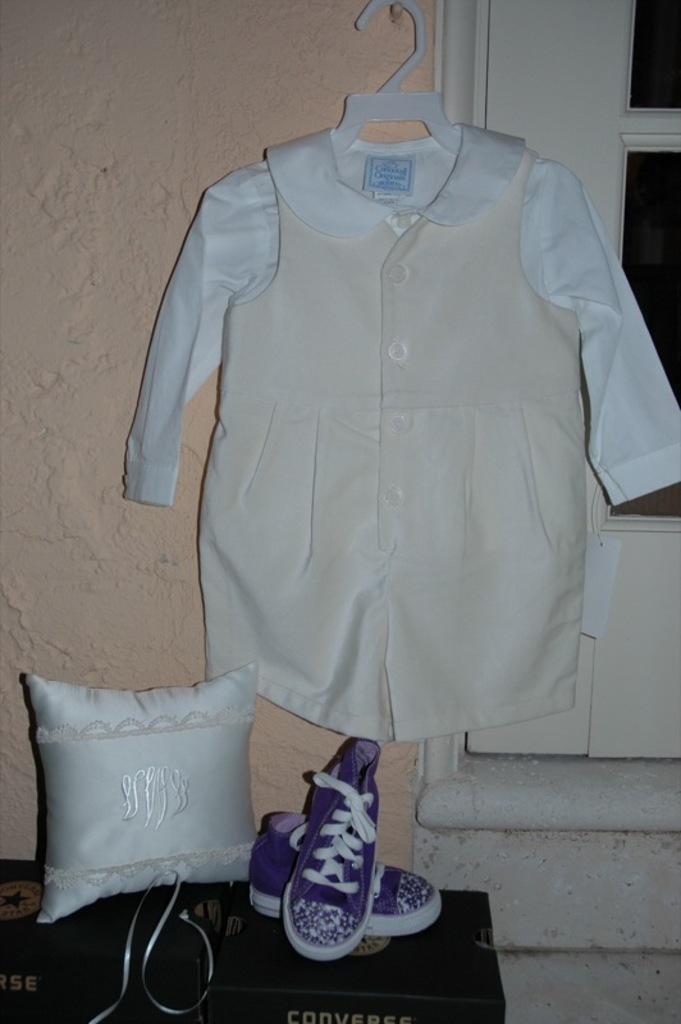In one or two sentences, can you explain what this image depicts? In this image there is a dress hanging on the wall, beside that there is a door, below the dress there is a pair of shoes and pillow are placed on some objects. 